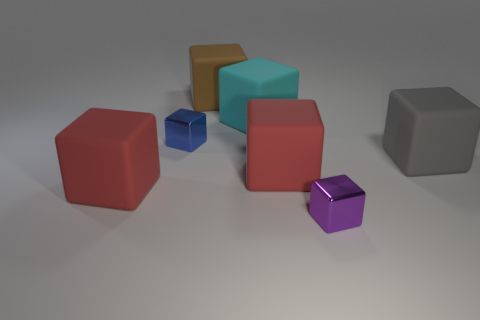Subtract all green balls. How many red cubes are left? 2 Add 2 big rubber things. How many objects exist? 9 Subtract all large gray blocks. How many blocks are left? 6 Subtract all brown blocks. How many blocks are left? 6 Subtract all brown cubes. Subtract all red balls. How many cubes are left? 6 Subtract all small blue metal cubes. Subtract all large green spheres. How many objects are left? 6 Add 6 purple things. How many purple things are left? 7 Add 4 tiny red shiny balls. How many tiny red shiny balls exist? 4 Subtract 0 purple cylinders. How many objects are left? 7 